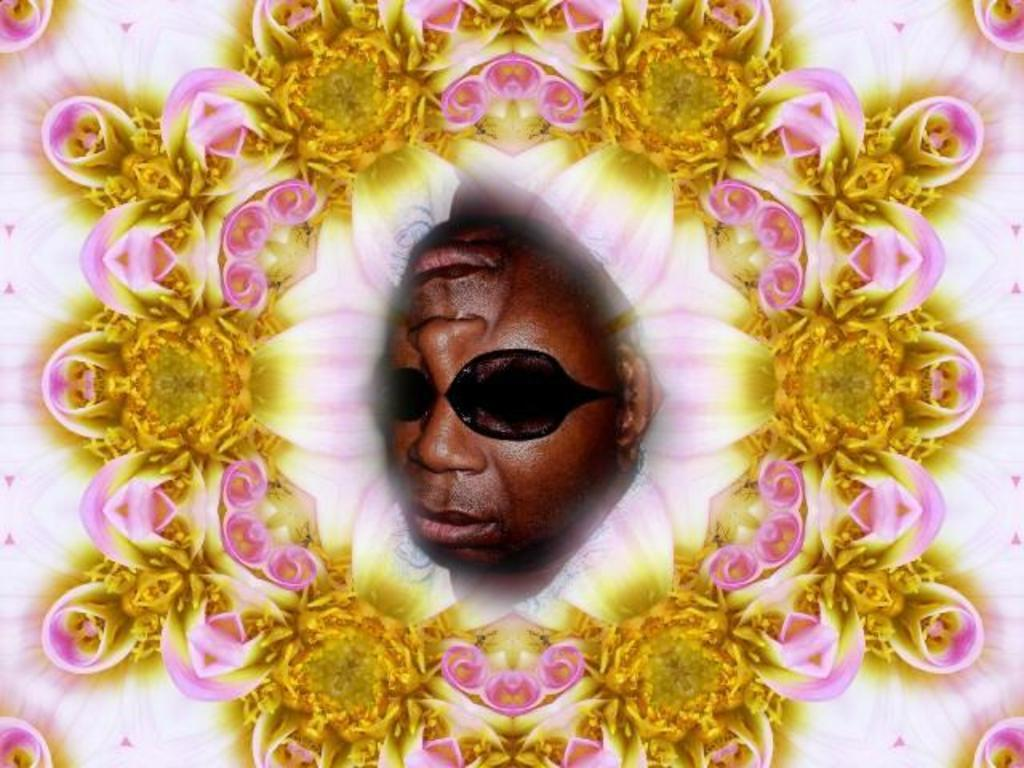What type of image is being described? The image is graphical. Can you identify any subjects or objects in the image? Yes, there is a person in the image. What type of button is the person wearing on their journey in the image? There is no button or journey mentioned in the image; it only contains a person in a graphical representation. 